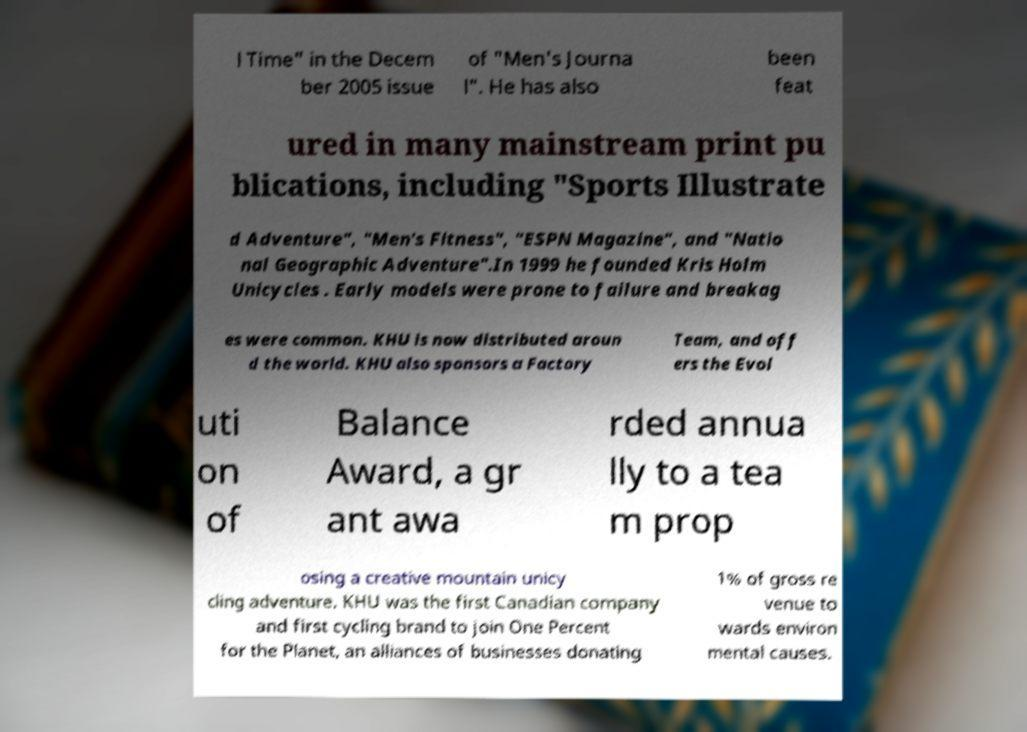Could you assist in decoding the text presented in this image and type it out clearly? l Time" in the Decem ber 2005 issue of "Men's Journa l". He has also been feat ured in many mainstream print pu blications, including "Sports Illustrate d Adventure", "Men's Fitness", "ESPN Magazine", and "Natio nal Geographic Adventure".In 1999 he founded Kris Holm Unicycles . Early models were prone to failure and breakag es were common. KHU is now distributed aroun d the world. KHU also sponsors a Factory Team, and off ers the Evol uti on of Balance Award, a gr ant awa rded annua lly to a tea m prop osing a creative mountain unicy cling adventure. KHU was the first Canadian company and first cycling brand to join One Percent for the Planet, an alliances of businesses donating 1% of gross re venue to wards environ mental causes. 